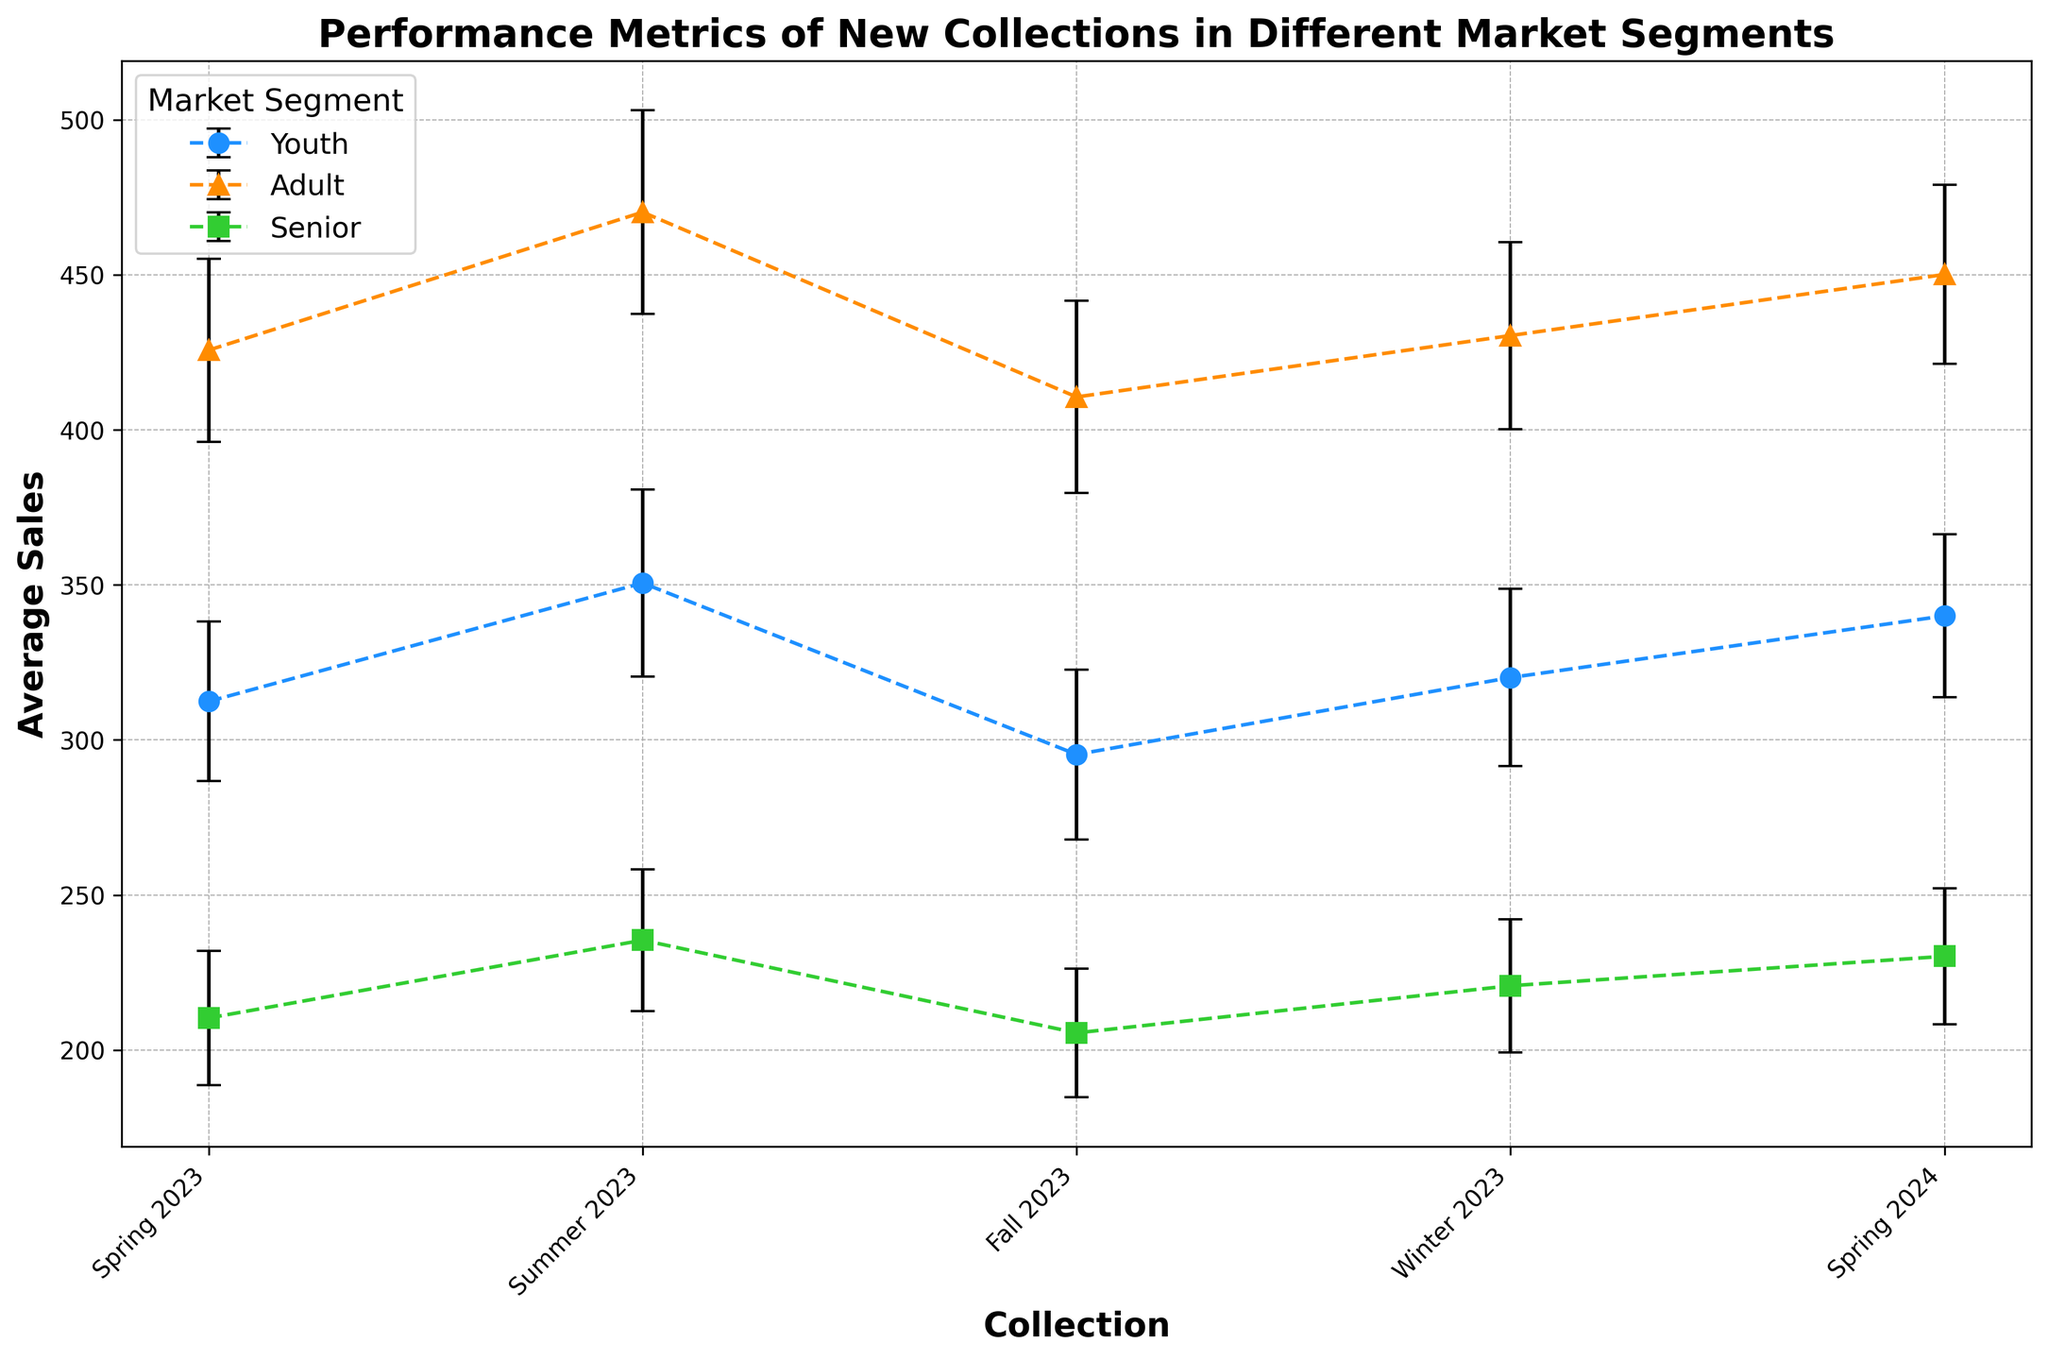Which market segment had the highest average sales in Summer 2023? First, locate the data points for Summer 2023. Then, compare the average sales for Youth, Adult, and Senior segments. The Adult segment has the highest data point.
Answer: Adult What is the difference in average sales between Spring 2023 and Spring 2024 for the Youth segment? Find the average sales for Youth in Spring 2023 and Spring 2024. The values are 312.4 and 340.0, respectively. Subtract the Spring 2023 value from the Spring 2024 value: 340.0 - 312.4.
Answer: 27.6 Which collection had the lowest average sales for the Senior segment? Locate the data points for the Senior segment across all collections. The lowest data point is for Fall 2023.
Answer: Fall 2023 How do the average sales for Winter 2023 compare between the Adult and Senior segments? Compare the data points for Winter 2023 between Adult and Senior segments. Adult sales are higher at 430.4 compared to 220.7 for Senior.
Answer: Adult has higher sales Which market segment shows the largest standard deviation in Summer 2023? Compare the standard deviation error bars for Summer 2023 across all segments. The Adult segment has the largest standard deviation with a value of 32.8.
Answer: Adult What is the sum of average sales for the Youth segment across all collections? Add the average sales for Youth across all collections: 312.4 (Spring 2023) + 350.6 (Summer 2023) + 295.3 (Fall 2023) + 320.1 (Winter 2023) + 340.0 (Spring 2024).
Answer: 1618.4 Do any segments have overlapping error bars in Summer 2023? Examine the error bars for all segments in Summer 2023. The Adult and Youth segments have overlapping error bars indicating the possibility of similar average sales within their standard deviations.
Answer: Yes What is the average sales difference between the Winter 2023 collections for Youth and Adult segments? Determine the average sales for Youth and Adult in Winter 2023 (320.1 and 430.4 respectively). Calculate the difference: 430.4 - 320.1.
Answer: 110.3 Which collection had the largest increase in average sales from Winter 2023 to Spring 2024 for any segment? Calculate the increase in average sales from Winter 2023 to Spring 2024 for each segment. The Youth segment shows the largest increase (340.0 - 320.1) = 19.9.
Answer: Youth 